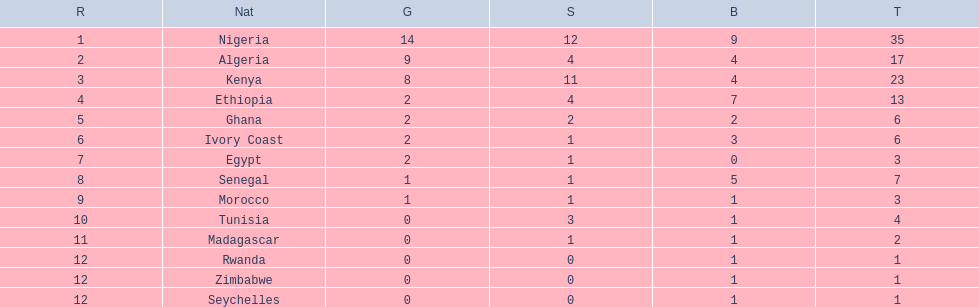What are all the nations? Nigeria, Algeria, Kenya, Ethiopia, Ghana, Ivory Coast, Egypt, Senegal, Morocco, Tunisia, Madagascar, Rwanda, Zimbabwe, Seychelles. How many bronze medals did they win? 9, 4, 4, 7, 2, 3, 0, 5, 1, 1, 1, 1, 1, 1. And which nation did not win one? Egypt. 